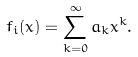Convert formula to latex. <formula><loc_0><loc_0><loc_500><loc_500>f _ { i } ( x ) = \sum _ { k = 0 } ^ { \infty } a _ { k } x ^ { k } .</formula> 